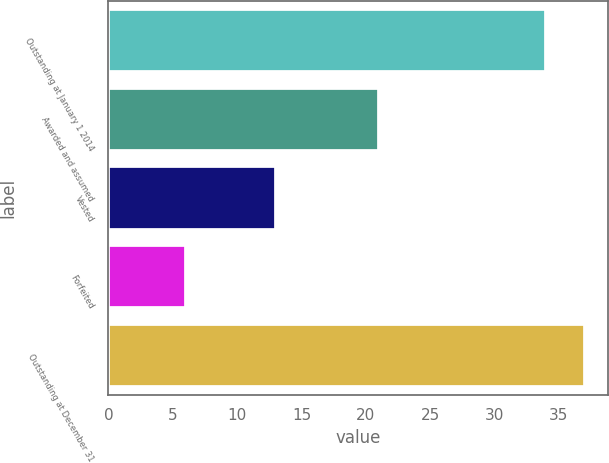<chart> <loc_0><loc_0><loc_500><loc_500><bar_chart><fcel>Outstanding at January 1 2014<fcel>Awarded and assumed<fcel>Vested<fcel>Forfeited<fcel>Outstanding at December 31<nl><fcel>34<fcel>21<fcel>13<fcel>6<fcel>37<nl></chart> 